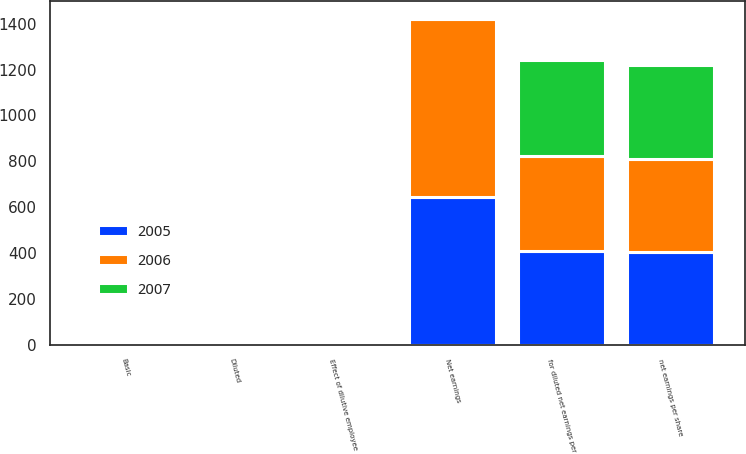<chart> <loc_0><loc_0><loc_500><loc_500><stacked_bar_chart><ecel><fcel>Net earnings<fcel>net earnings per share<fcel>Effect of dilutive employee<fcel>for diluted net earnings per<fcel>Basic<fcel>Diluted<nl><fcel>2007<fcel>7.5<fcel>409.7<fcel>7.5<fcel>417.2<fcel>2.48<fcel>2.44<nl><fcel>2006<fcel>777.7<fcel>406.5<fcel>5.3<fcel>411.8<fcel>1.91<fcel>1.89<nl><fcel>2005<fcel>643.6<fcel>403.7<fcel>7.1<fcel>410.8<fcel>1.59<fcel>1.57<nl></chart> 